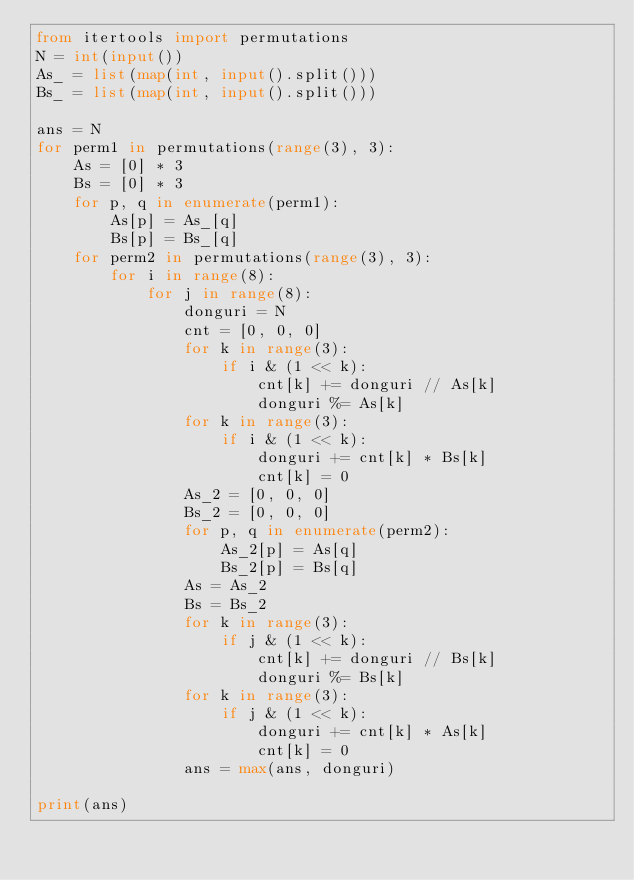Convert code to text. <code><loc_0><loc_0><loc_500><loc_500><_Python_>from itertools import permutations
N = int(input())
As_ = list(map(int, input().split()))
Bs_ = list(map(int, input().split()))

ans = N
for perm1 in permutations(range(3), 3):
    As = [0] * 3
    Bs = [0] * 3
    for p, q in enumerate(perm1):
        As[p] = As_[q]
        Bs[p] = Bs_[q]
    for perm2 in permutations(range(3), 3):
        for i in range(8):
            for j in range(8):
                donguri = N
                cnt = [0, 0, 0]
                for k in range(3):
                    if i & (1 << k):
                        cnt[k] += donguri // As[k]
                        donguri %= As[k]
                for k in range(3):
                    if i & (1 << k):
                        donguri += cnt[k] * Bs[k]
                        cnt[k] = 0
                As_2 = [0, 0, 0]
                Bs_2 = [0, 0, 0]
                for p, q in enumerate(perm2):
                    As_2[p] = As[q]
                    Bs_2[p] = Bs[q]
                As = As_2
                Bs = Bs_2
                for k in range(3):
                    if j & (1 << k):
                        cnt[k] += donguri // Bs[k]
                        donguri %= Bs[k]
                for k in range(3):
                    if j & (1 << k):
                        donguri += cnt[k] * As[k]
                        cnt[k] = 0
                ans = max(ans, donguri)
                
print(ans)</code> 